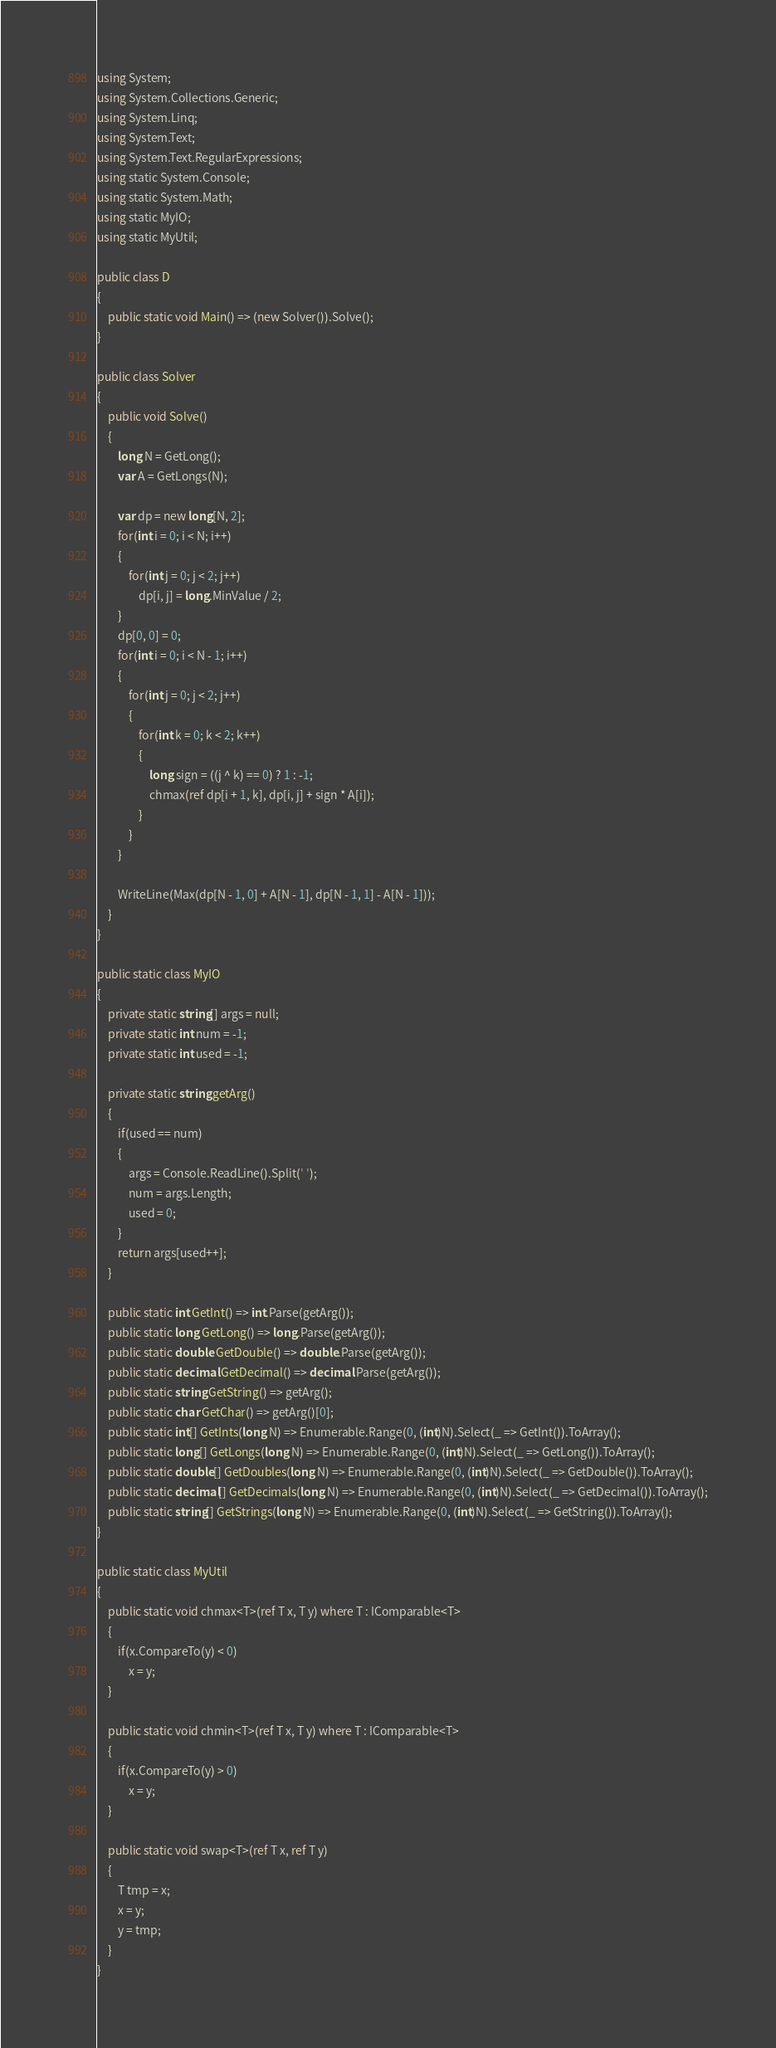<code> <loc_0><loc_0><loc_500><loc_500><_C#_>using System;
using System.Collections.Generic;
using System.Linq;
using System.Text;
using System.Text.RegularExpressions;
using static System.Console;
using static System.Math;
using static MyIO;
using static MyUtil;

public class D
{
	public static void Main() => (new Solver()).Solve();
}

public class Solver
{
	public void Solve()
	{
		long N = GetLong();
		var A = GetLongs(N);

		var dp = new long[N, 2];
		for(int i = 0; i < N; i++)
		{
			for(int j = 0; j < 2; j++)
				dp[i, j] = long.MinValue / 2;
		}
		dp[0, 0] = 0;
		for(int i = 0; i < N - 1; i++)
		{
			for(int j = 0; j < 2; j++)
			{
				for(int k = 0; k < 2; k++)
				{
					long sign = ((j ^ k) == 0) ? 1 : -1;
					chmax(ref dp[i + 1, k], dp[i, j] + sign * A[i]);
				}
			}
		}

		WriteLine(Max(dp[N - 1, 0] + A[N - 1], dp[N - 1, 1] - A[N - 1]));
	}
}

public static class MyIO
{
	private static string[] args = null;
	private static int num = -1;
	private static int used = -1;

	private static string getArg()
	{
		if(used == num)
		{
			args = Console.ReadLine().Split(' ');
			num = args.Length;
			used = 0;
		}
		return args[used++];
	}

	public static int GetInt() => int.Parse(getArg());
	public static long GetLong() => long.Parse(getArg());
	public static double GetDouble() => double.Parse(getArg());
	public static decimal GetDecimal() => decimal.Parse(getArg());
	public static string GetString() => getArg();
	public static char GetChar() => getArg()[0];
	public static int[] GetInts(long N) => Enumerable.Range(0, (int)N).Select(_ => GetInt()).ToArray();
	public static long[] GetLongs(long N) => Enumerable.Range(0, (int)N).Select(_ => GetLong()).ToArray();
	public static double[] GetDoubles(long N) => Enumerable.Range(0, (int)N).Select(_ => GetDouble()).ToArray();
	public static decimal[] GetDecimals(long N) => Enumerable.Range(0, (int)N).Select(_ => GetDecimal()).ToArray();
	public static string[] GetStrings(long N) => Enumerable.Range(0, (int)N).Select(_ => GetString()).ToArray();
}

public static class MyUtil
{
	public static void chmax<T>(ref T x, T y) where T : IComparable<T>
	{
		if(x.CompareTo(y) < 0)
			x = y;
	}

	public static void chmin<T>(ref T x, T y) where T : IComparable<T>
	{
		if(x.CompareTo(y) > 0)
			x = y;
	}

	public static void swap<T>(ref T x, ref T y)
	{
		T tmp = x;
		x = y;
		y = tmp;
	}
}</code> 